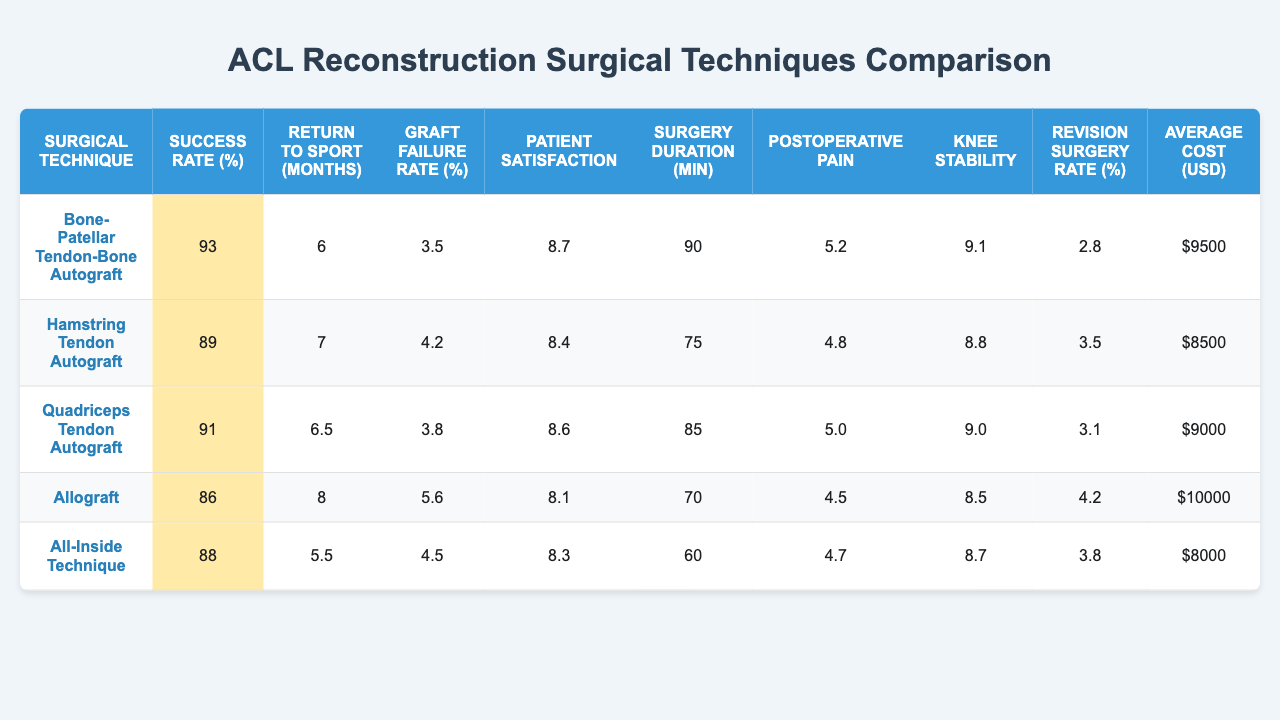What is the success rate percentage for the Bone-Patellar Tendon-Bone Autograft? The table shows the success rate percentage for each surgical technique. For the Bone-Patellar Tendon-Bone Autograft, the success rate percentage listed is 93%.
Answer: 93% How long does it take on average for athletes to return to sport after using the Allograft technique? The table indicates the average return to sport time for each technique. For the Allograft, it takes 8 months on average to return to sport.
Answer: 8 months Which surgical technique has the highest graft failure rate percentage? By comparing the graft failure rates across all techniques in the table, the Allograft has the highest graft failure rate at 5.6%.
Answer: Allograft What is the average cost of the Hamstring Tendon Autograft? The table lists the average cost of the Hamstring Tendon Autograft, which is $8500.
Answer: $8500 Is the Patient Satisfaction Score higher for the Quadriceps Tendon Autograft than the All-Inside Technique? Looking at the Patient Satisfaction Scores, the Quadriceps Tendon Autograft has a score of 8.6, while the All-Inside Technique has a score of 8.3. Therefore, the Quadriceps Tendon Autograft has a higher score.
Answer: Yes What is the average return to sport time across all techniques? To find the average return to sport time, sum the return times (6 + 7 + 6.5 + 8 + 5.5 = 33) and divide by the number of techniques (5), resulting in an average of 33/5 = 6.6 months.
Answer: 6.6 months Which technique has the lowest average surgery duration? The table provides the duration for each technique, where the All-Inside Technique has the lowest average surgery duration listed at 60 minutes.
Answer: All-Inside Technique If a patient reports a postoperative pain score of 5.0, which technique might they have used? Looking at the Postoperative Pain Scores, a score of 5.0 corresponds to the Quadriceps Tendon Autograft technique.
Answer: Quadriceps Tendon Autograft What is the difference between the success rate percentage of the Bone-Patellar Tendon-Bone Autograft and the Hamstring Tendon Autograft? The success rate for the Bone-Patellar Tendon-Bone Autograft is 93%, and for the Hamstring Tendon Autograft, it is 89%. The difference is 93 - 89 = 4%.
Answer: 4% Do the techniques with higher success rates also have lower revision surgery rates? Comparing the rates, the Bone-Patellar Tendon-Bone Autograft has the highest success rate (93%) and the lowest revision rate (2.8%). The trend continues with Hamstring Tendon Autograft (89% success rate, 3.5% revision rate) and so forth, indicating a negative correlation between success and revision rates.
Answer: Yes 